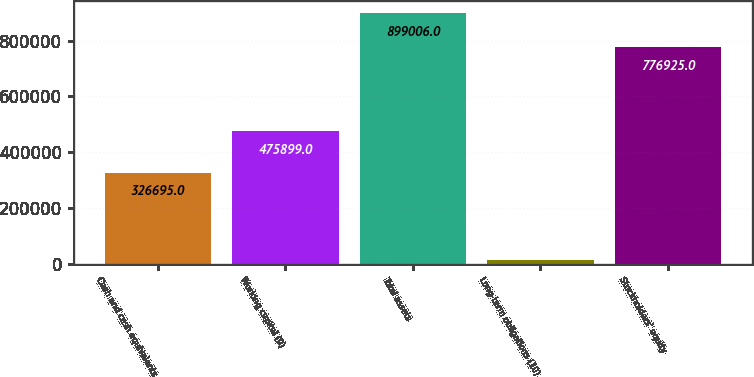Convert chart to OTSL. <chart><loc_0><loc_0><loc_500><loc_500><bar_chart><fcel>Cash and cash equivalents<fcel>Working capital (9)<fcel>Total assets<fcel>Long-term obligations (10)<fcel>Stockholders' equity<nl><fcel>326695<fcel>475899<fcel>899006<fcel>11515<fcel>776925<nl></chart> 